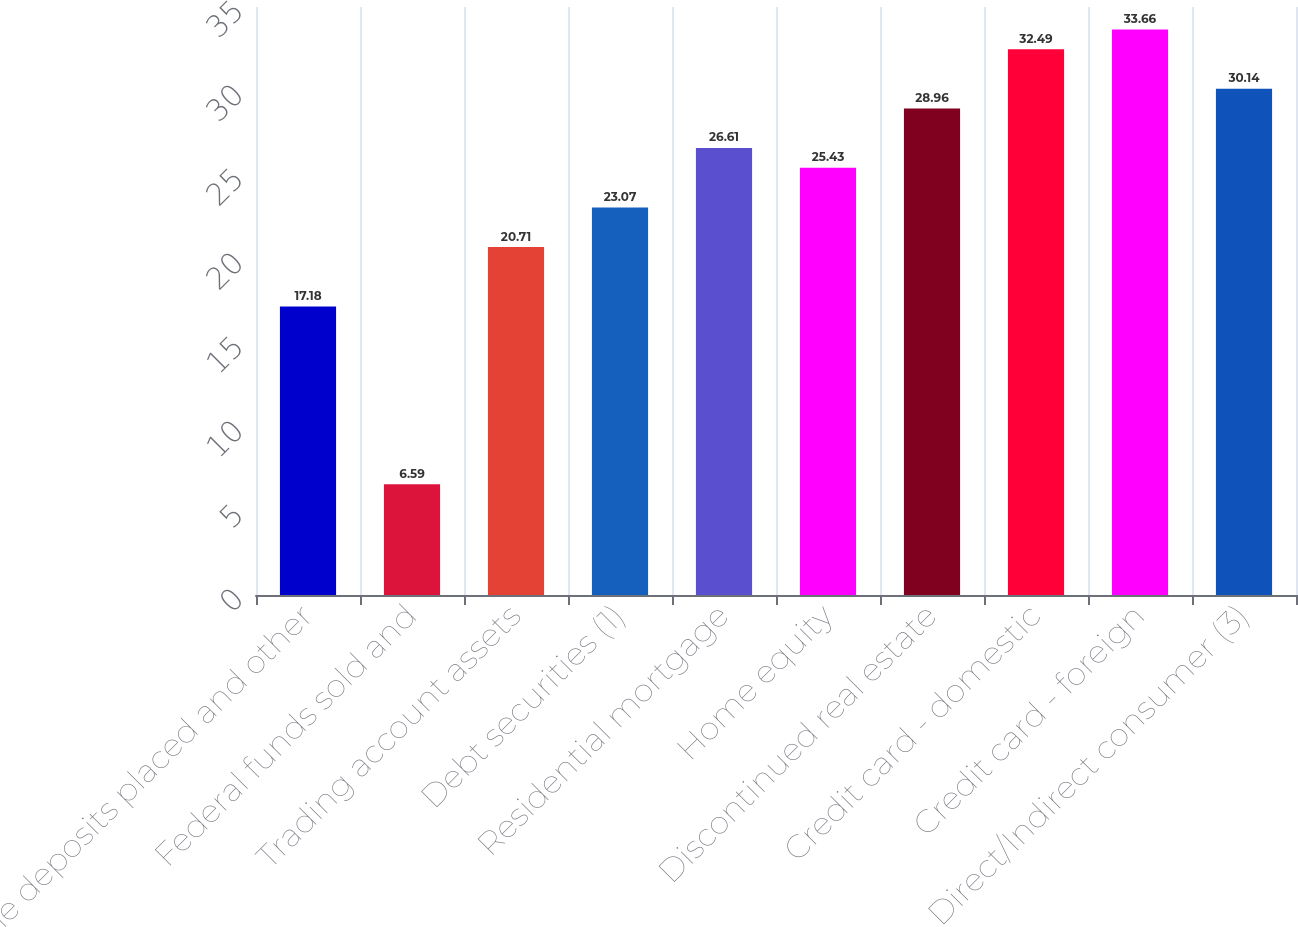Convert chart. <chart><loc_0><loc_0><loc_500><loc_500><bar_chart><fcel>Time deposits placed and other<fcel>Federal funds sold and<fcel>Trading account assets<fcel>Debt securities (1)<fcel>Residential mortgage<fcel>Home equity<fcel>Discontinued real estate<fcel>Credit card - domestic<fcel>Credit card - foreign<fcel>Direct/Indirect consumer (3)<nl><fcel>17.18<fcel>6.59<fcel>20.71<fcel>23.07<fcel>26.61<fcel>25.43<fcel>28.96<fcel>32.49<fcel>33.66<fcel>30.14<nl></chart> 